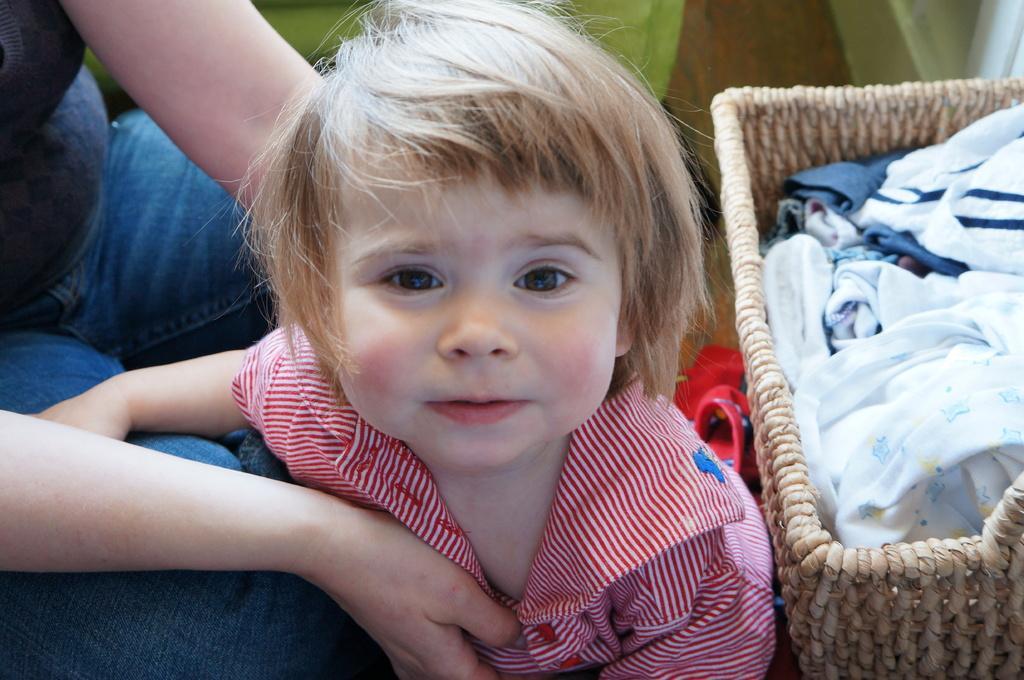In one or two sentences, can you explain what this image depicts? In this image I can see a little girl, she wore white and red color t-shirt. On the right side there is a basket with clothes. 